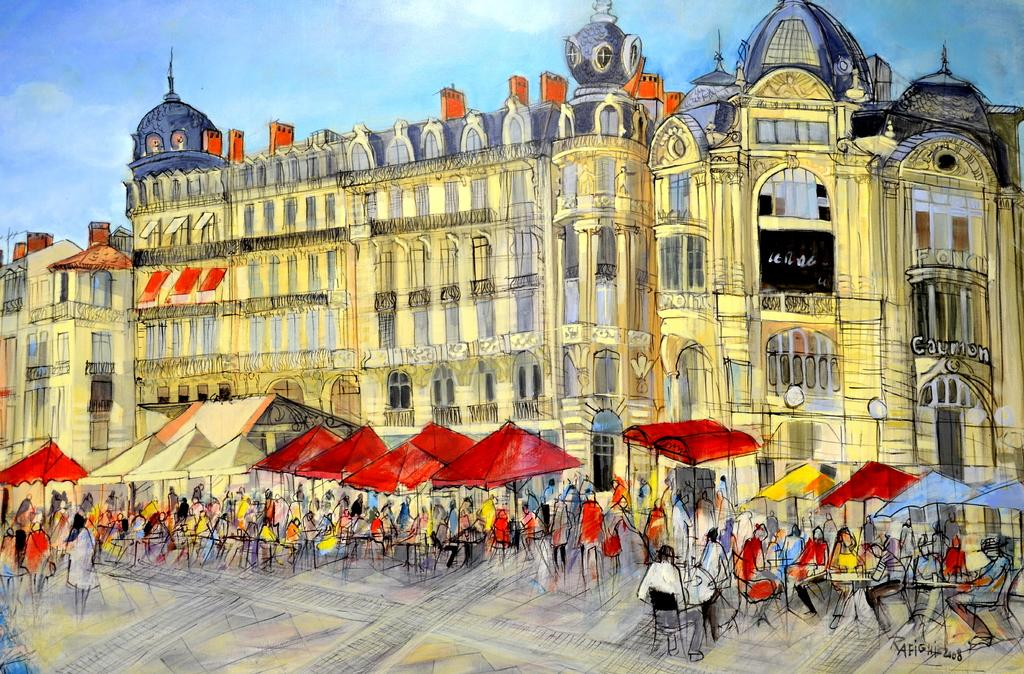What is the main subject of the image? The main subject of the image is a painting. What is being depicted in the painting? The painting depicts buildings, including windows. Are there any objects or elements related to weather in the painting? Yes, umbrellas are present in the painting. Are there any people in the painting? Yes, there are people in the painting. What type of furniture is depicted in the painting? Chairs and tables are present in the painting. What can be seen at the top of the painting? The sky is visible at the top of the painting. What type of pest can be seen crawling on the buildings in the painting? There are no pests visible in the painting; it depicts buildings, windows, umbrellas, people, chairs, tables, and the sky. What type of farming equipment is present in the painting? There is no farming equipment, such as a plough, depicted in the painting. 